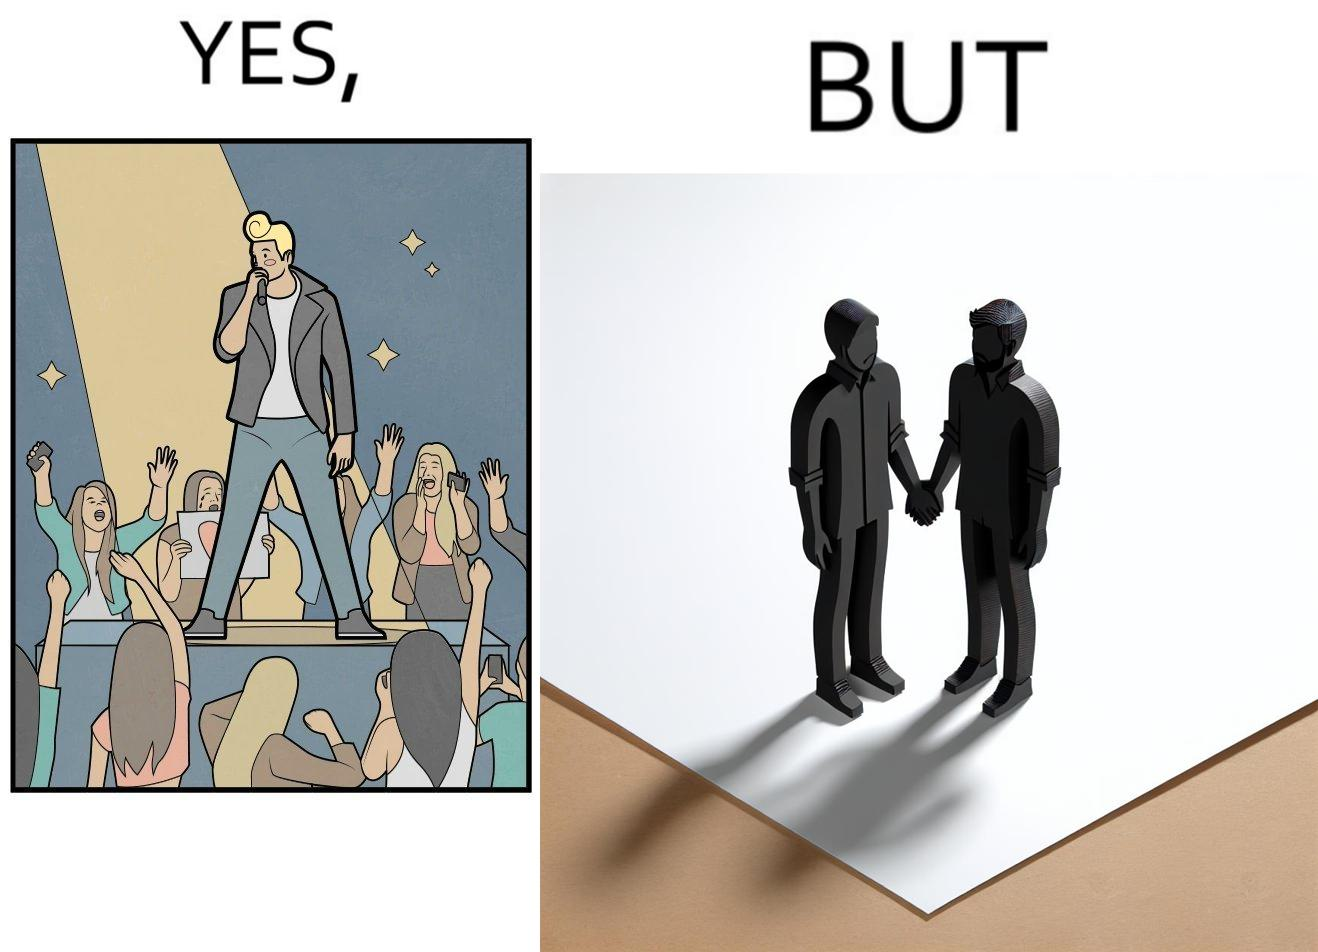What do you see in each half of this image? In the left part of the image: The person shows a man singing on a platform under a spotlight. There are several girls around the platform enjoying his singing and cheering for him. A few girls are taking his photos using their phone and a few also have a poster with heart drawn on it. In the right part of the image: The image shows two men holding hands. 